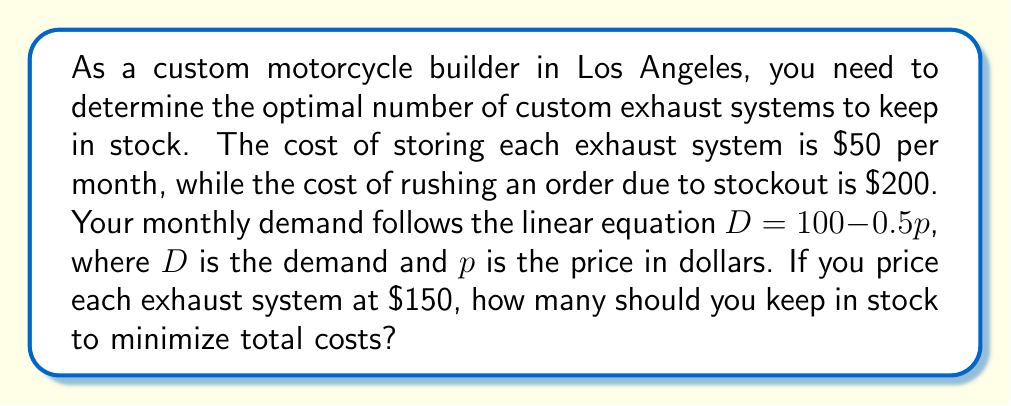Provide a solution to this math problem. 1) First, calculate the monthly demand at the given price:
   $D = 100 - 0.5p$
   $D = 100 - 0.5(150) = 100 - 75 = 25$ exhaust systems

2) To find the optimal inventory level, we need to balance storage costs with stockout costs. The optimal point is where these costs are equal.

3) Let $x$ be the number of exhaust systems in stock.
   Storage cost: $50x$
   Probability of stockout: $(25-x)/25$ (assuming uniform distribution of demand)
   Expected stockout cost: $200(25-x)/25$

4) Set these costs equal:
   $50x = 200(25-x)/25$

5) Solve the equation:
   $50x = 200 - 8x$
   $58x = 200$
   $x = 200/58 \approx 3.45$

6) Since we can't stock fractional exhaust systems, we round to the nearest whole number: 3.
Answer: 3 exhaust systems 